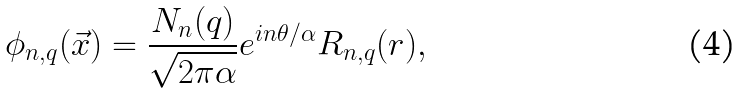<formula> <loc_0><loc_0><loc_500><loc_500>\phi _ { n , q } ( { \vec { x } } ) = { \frac { N _ { n } ( q ) } { \sqrt { 2 \pi \alpha } } } e ^ { i n \theta / \alpha } R _ { n , q } ( r ) ,</formula> 